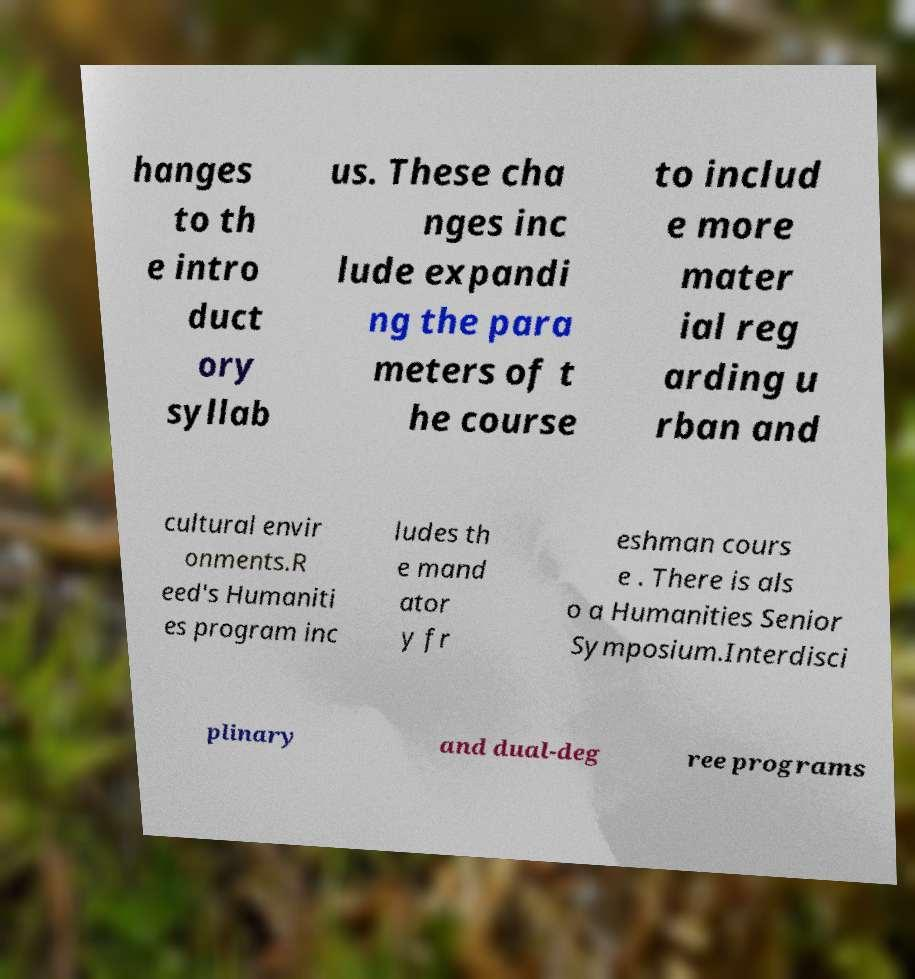There's text embedded in this image that I need extracted. Can you transcribe it verbatim? hanges to th e intro duct ory syllab us. These cha nges inc lude expandi ng the para meters of t he course to includ e more mater ial reg arding u rban and cultural envir onments.R eed's Humaniti es program inc ludes th e mand ator y fr eshman cours e . There is als o a Humanities Senior Symposium.Interdisci plinary and dual-deg ree programs 